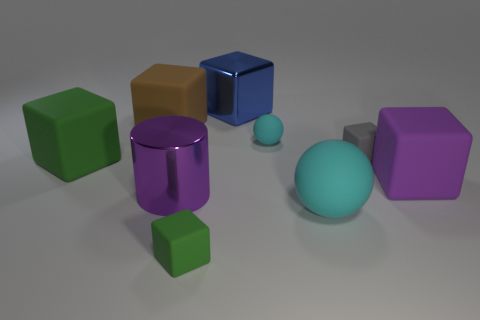What is the material of the cube that is the same color as the cylinder?
Offer a very short reply. Rubber. What number of other objects are there of the same color as the small sphere?
Offer a very short reply. 1. What number of things are either purple metallic cylinders or small matte cubes?
Offer a terse response. 3. There is a big object to the right of the gray matte object; is it the same shape as the gray thing?
Make the answer very short. Yes. The cube in front of the object right of the small gray cube is what color?
Give a very brief answer. Green. Are there fewer large brown cubes than green cylinders?
Offer a terse response. No. Are there any tiny gray cubes made of the same material as the large green thing?
Offer a very short reply. Yes. Do the large green object and the large metallic thing in front of the big green matte object have the same shape?
Keep it short and to the point. No. There is a brown block; are there any large metallic objects in front of it?
Ensure brevity in your answer.  Yes. How many tiny objects have the same shape as the large green rubber object?
Provide a short and direct response. 2. 